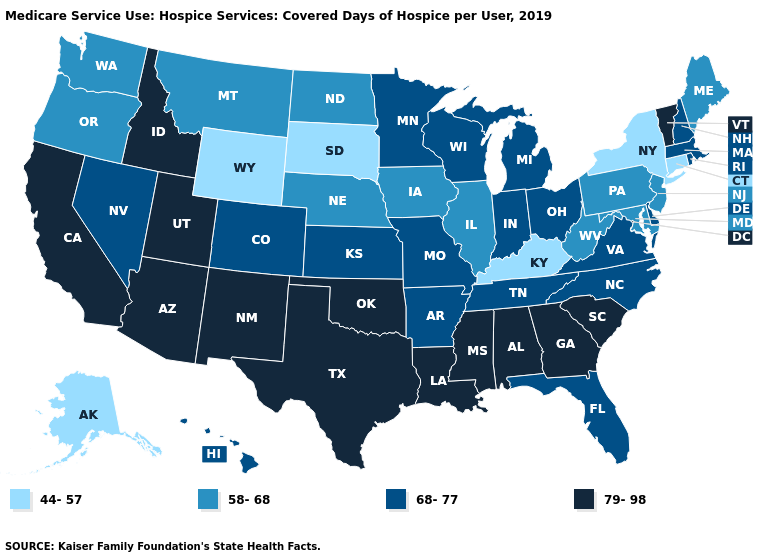Among the states that border Vermont , does New York have the lowest value?
Give a very brief answer. Yes. Name the states that have a value in the range 44-57?
Answer briefly. Alaska, Connecticut, Kentucky, New York, South Dakota, Wyoming. Does the map have missing data?
Short answer required. No. Among the states that border Massachusetts , does New York have the highest value?
Concise answer only. No. Does Maine have a higher value than Wyoming?
Answer briefly. Yes. Name the states that have a value in the range 79-98?
Write a very short answer. Alabama, Arizona, California, Georgia, Idaho, Louisiana, Mississippi, New Mexico, Oklahoma, South Carolina, Texas, Utah, Vermont. What is the value of Texas?
Answer briefly. 79-98. Name the states that have a value in the range 44-57?
Keep it brief. Alaska, Connecticut, Kentucky, New York, South Dakota, Wyoming. Is the legend a continuous bar?
Write a very short answer. No. How many symbols are there in the legend?
Short answer required. 4. Which states have the lowest value in the South?
Quick response, please. Kentucky. What is the value of Virginia?
Keep it brief. 68-77. Name the states that have a value in the range 44-57?
Answer briefly. Alaska, Connecticut, Kentucky, New York, South Dakota, Wyoming. What is the lowest value in the West?
Keep it brief. 44-57. What is the value of West Virginia?
Short answer required. 58-68. 